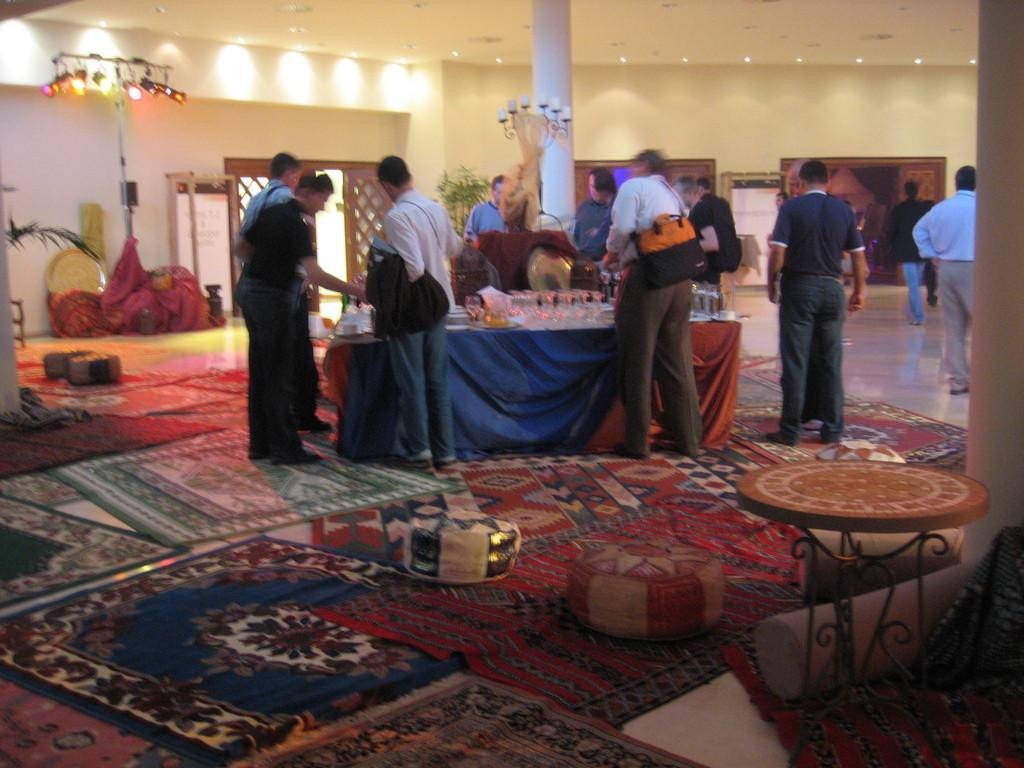Please provide a concise description of this image. In this image I see number of people and I see the floor on which there are carpets and I see a table over here on which there are glasses and other things and I can also see another table over here. In the background I see the lights over here which are colorful and I see planets and I see few more lights on the ceiling and I see the wall. 